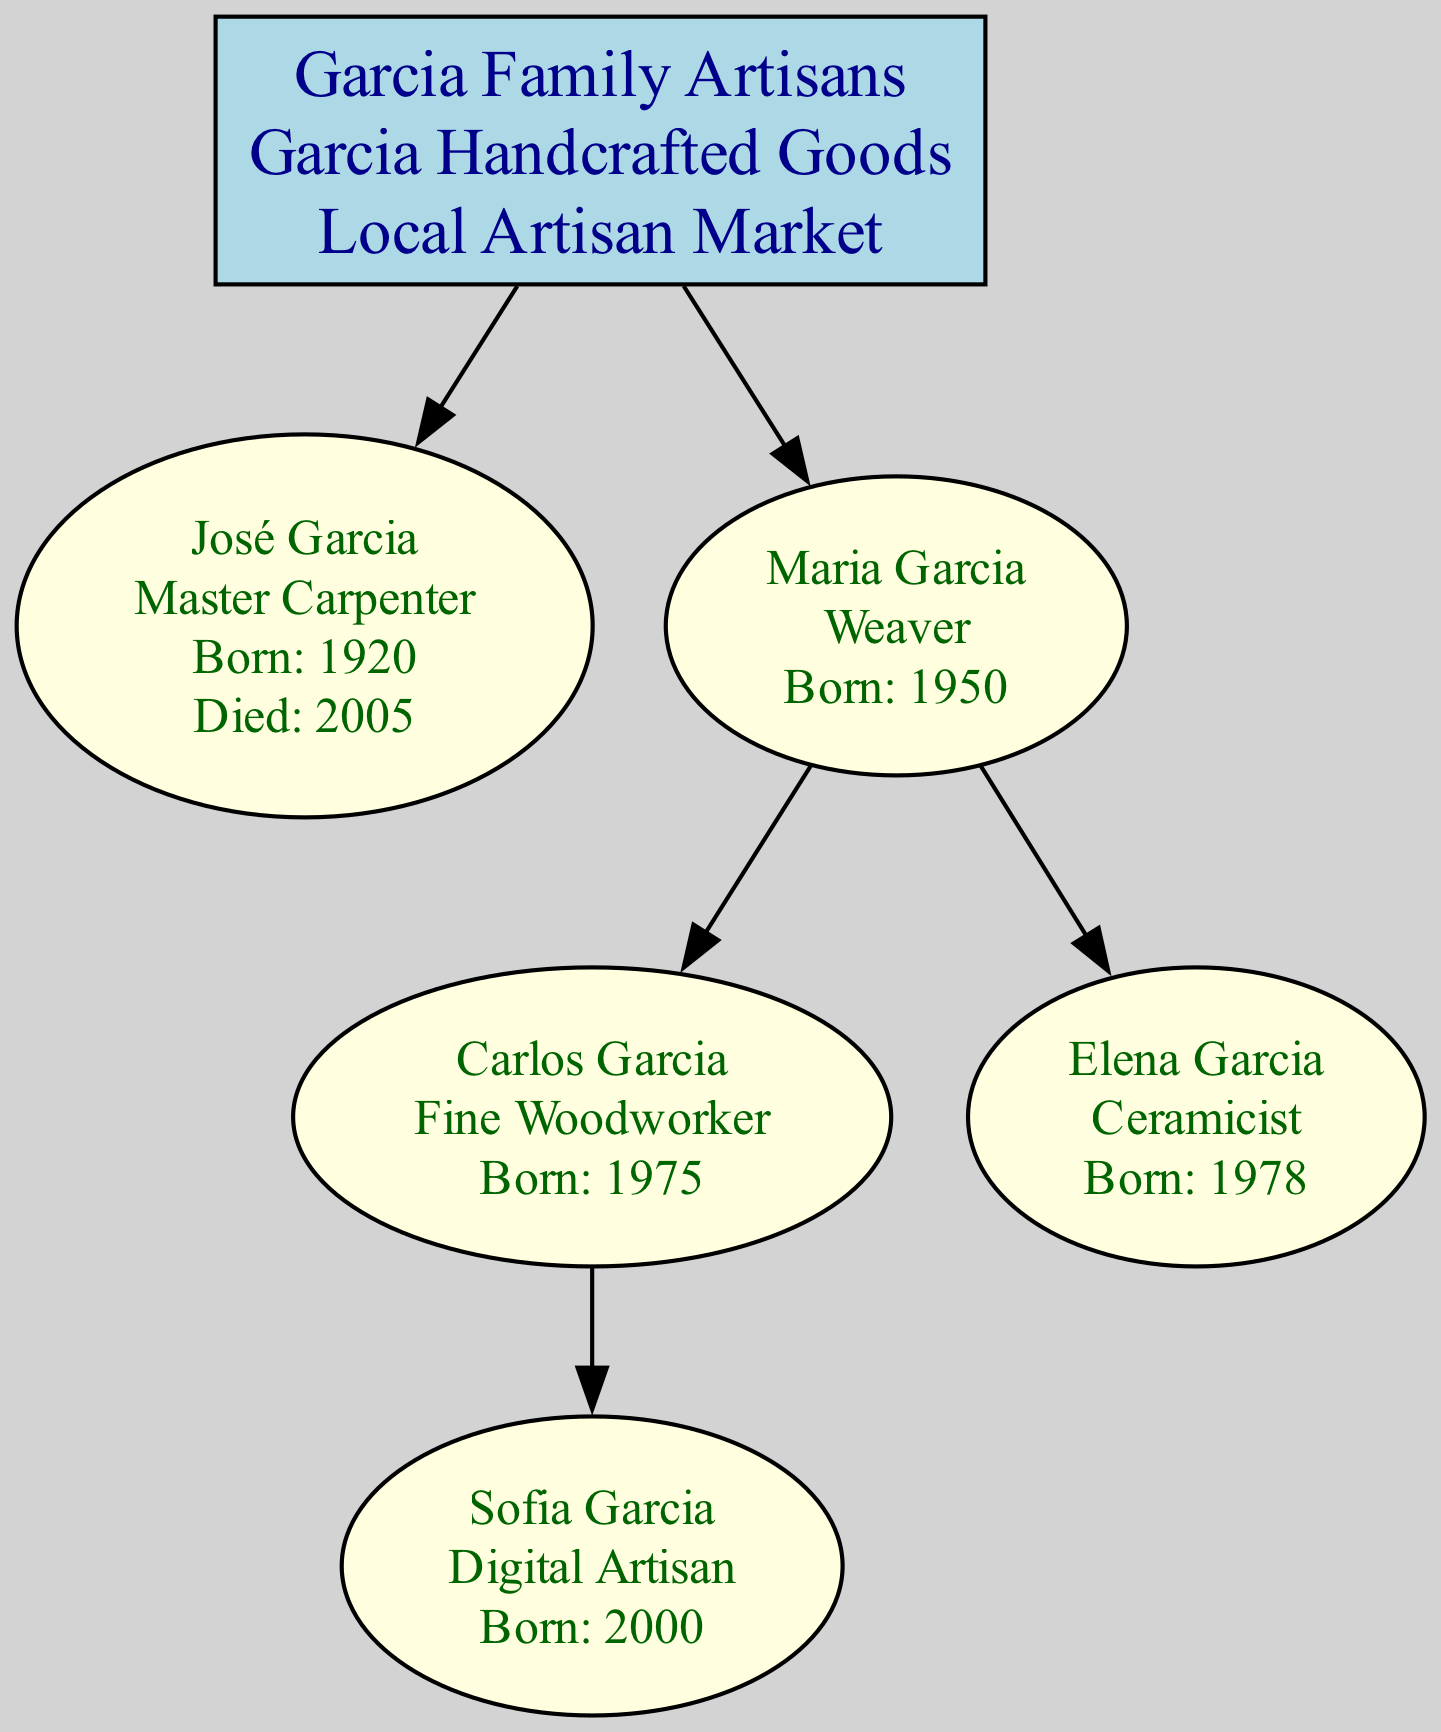What is the trade of José Garcia? In the diagram, José Garcia is listed directly under the root node of the Garcia Family Artisans. His trade is specifically mentioned next to his name as "Master Carpenter."
Answer: Master Carpenter How many children does Maria Garcia have? Looking at the node for Maria Garcia, there is a link to two child nodes: Carlos Garcia and Elena Garcia. This indicates that Maria Garcia has two children.
Answer: 2 Who is the youngest artisan in the family? By analyzing the nodes, Sofia Garcia is born in 2000, which makes her the youngest in the lineage since the other artisans have earlier birth years.
Answer: Sofia Garcia What is the relationship between Carlos Garcia and Elena Garcia? The diagram shows that both Carlos Garcia and Elena Garcia share the same parent, Maria Garcia, indicating they are siblings.
Answer: Siblings What skill does Sofia Garcia inherit from her father? Sofia Garcia is the child of Carlos Garcia, who is a "Fine Woodworker." Thus, Sofia Garcia, identified as a "Digital Artisan," inherits the skill of woodworking, through her father's trade.
Answer: Woodworking How many generations are represented in the family tree? The tree includes the root family, José and Maria Garcia, as well as their children Carlos and Elena, and Carlos's child Sofia. Thus, there are three generations represented: the root, Maria's generation, and Carlos's generation.
Answer: 3 What is the primary family business? The family business is explicitly mentioned in the root node as "Garcia Handcrafted Goods," showing the common enterprise of the artisan family.
Answer: Garcia Handcrafted Goods Which artisan specializes in ceramics? The diagram specifies Elena Garcia's trade as "Ceramicist," indicating she specializes in ceramics.
Answer: Ceramicist Where is the family business located? The location of the family business is stated in the root node as "Local Artisan Market," which tells us where they operate.
Answer: Local Artisan Market 